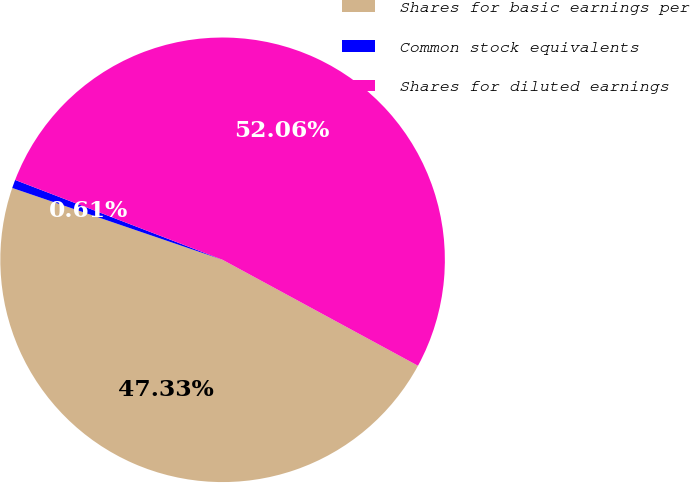<chart> <loc_0><loc_0><loc_500><loc_500><pie_chart><fcel>Shares for basic earnings per<fcel>Common stock equivalents<fcel>Shares for diluted earnings<nl><fcel>47.33%<fcel>0.61%<fcel>52.06%<nl></chart> 